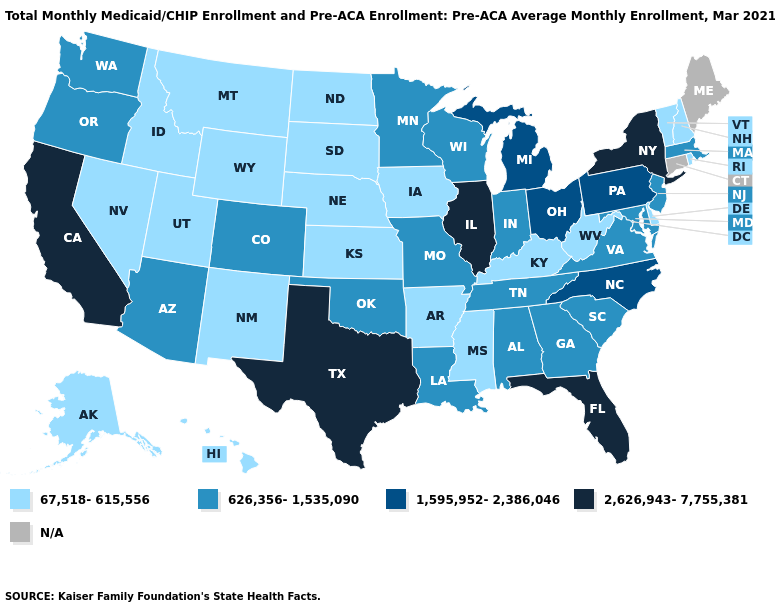What is the value of Minnesota?
Keep it brief. 626,356-1,535,090. Among the states that border Delaware , does Pennsylvania have the lowest value?
Answer briefly. No. Does Idaho have the lowest value in the USA?
Be succinct. Yes. What is the value of New Hampshire?
Quick response, please. 67,518-615,556. Does Alabama have the lowest value in the South?
Concise answer only. No. Name the states that have a value in the range N/A?
Concise answer only. Connecticut, Maine. What is the value of Utah?
Keep it brief. 67,518-615,556. Which states have the lowest value in the USA?
Write a very short answer. Alaska, Arkansas, Delaware, Hawaii, Idaho, Iowa, Kansas, Kentucky, Mississippi, Montana, Nebraska, Nevada, New Hampshire, New Mexico, North Dakota, Rhode Island, South Dakota, Utah, Vermont, West Virginia, Wyoming. Name the states that have a value in the range 626,356-1,535,090?
Answer briefly. Alabama, Arizona, Colorado, Georgia, Indiana, Louisiana, Maryland, Massachusetts, Minnesota, Missouri, New Jersey, Oklahoma, Oregon, South Carolina, Tennessee, Virginia, Washington, Wisconsin. What is the lowest value in states that border Alabama?
Keep it brief. 67,518-615,556. Which states have the lowest value in the South?
Concise answer only. Arkansas, Delaware, Kentucky, Mississippi, West Virginia. Is the legend a continuous bar?
Answer briefly. No. Does New Jersey have the lowest value in the Northeast?
Quick response, please. No. How many symbols are there in the legend?
Concise answer only. 5. Name the states that have a value in the range N/A?
Be succinct. Connecticut, Maine. 